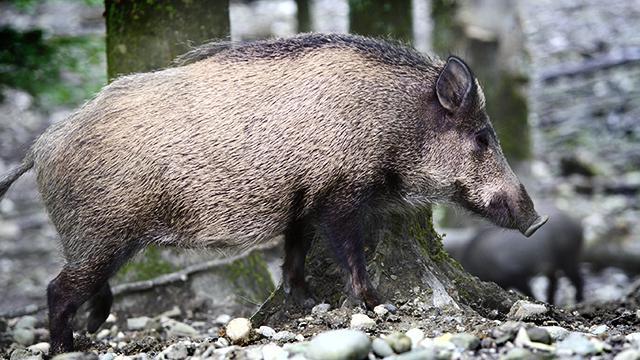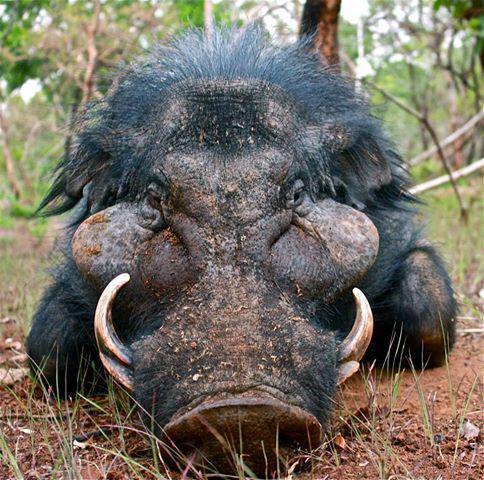The first image is the image on the left, the second image is the image on the right. Assess this claim about the two images: "There are baby boars in the image on the left.". Correct or not? Answer yes or no. No. 